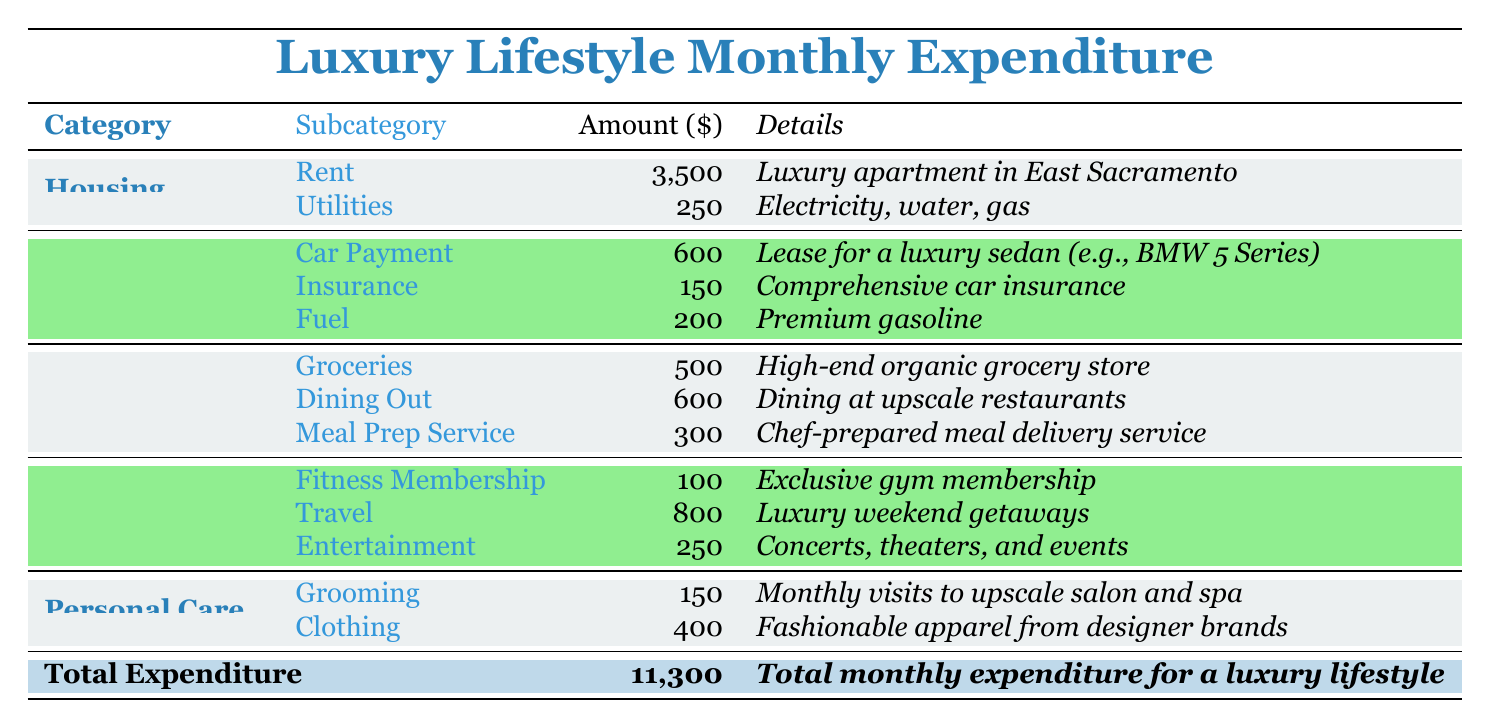What is the total amount spent on housing? To find the total spent on housing, add the amounts for Rent (3500) and Utilities (250). So, 3500 + 250 = 3750.
Answer: 3750 How much is allocated monthly for dining out? The amount allocated for dining out is directly listed in the Food category under Dining Out, which is 600.
Answer: 600 Is the amount spent on leisure higher than the amount spent on transportation? To find this, calculate the total for Leisure (100 + 800 + 250 = 1150) and compare it with Transportation (600 + 150 + 200 = 950). Since 1150 is greater than 950, the statement is true.
Answer: Yes What is the total expenditure on personal care? To find personal care expenditure, add Grooming (150) and Clothing (400). Thus, 150 + 400 = 550.
Answer: 550 What is the average monthly expenditure across all categories? First, calculate the total expenditure (11300), then divide it by the number of categories (5 categories: Housing, Transportation, Food, Leisure, Personal Care). So, 11300 / 5 = 2260.
Answer: 2260 How much is spent on groceries compared to the total expenditure? The expenditure on groceries is 500. To compare it to the total expenditure (11300), we note that 500 is much less than 11300, meaning groceries represent a small portion.
Answer: 500 Is the spending on travel greater than the spending on car payment? Travel is 800, while Car Payment is 600. Since 800 is greater than 600, the statement is true.
Answer: Yes What is the total amount spent on food? Calculate the total by summing the amounts for Groceries (500), Dining Out (600), and Meal Prep Service (300). Therefore, 500 + 600 + 300 = 1400.
Answer: 1400 How much more is spent on travel than on entertainment? Travel costs 800, and Entertainment costs 250. The difference is calculated as 800 - 250 = 550.
Answer: 550 What percentage of the total expenditure is allocated to utilities? The amount for Utilities is 250. To find the percentage of the total (11300), calculate (250 / 11300) * 100 which equals approximately 2.21%.
Answer: 2.21% 